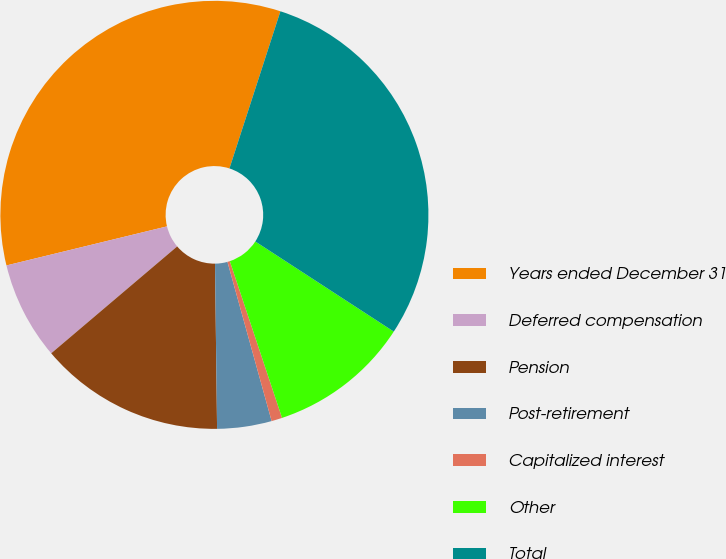<chart> <loc_0><loc_0><loc_500><loc_500><pie_chart><fcel>Years ended December 31<fcel>Deferred compensation<fcel>Pension<fcel>Post-retirement<fcel>Capitalized interest<fcel>Other<fcel>Total<nl><fcel>33.79%<fcel>7.4%<fcel>14.0%<fcel>4.11%<fcel>0.81%<fcel>10.7%<fcel>29.19%<nl></chart> 